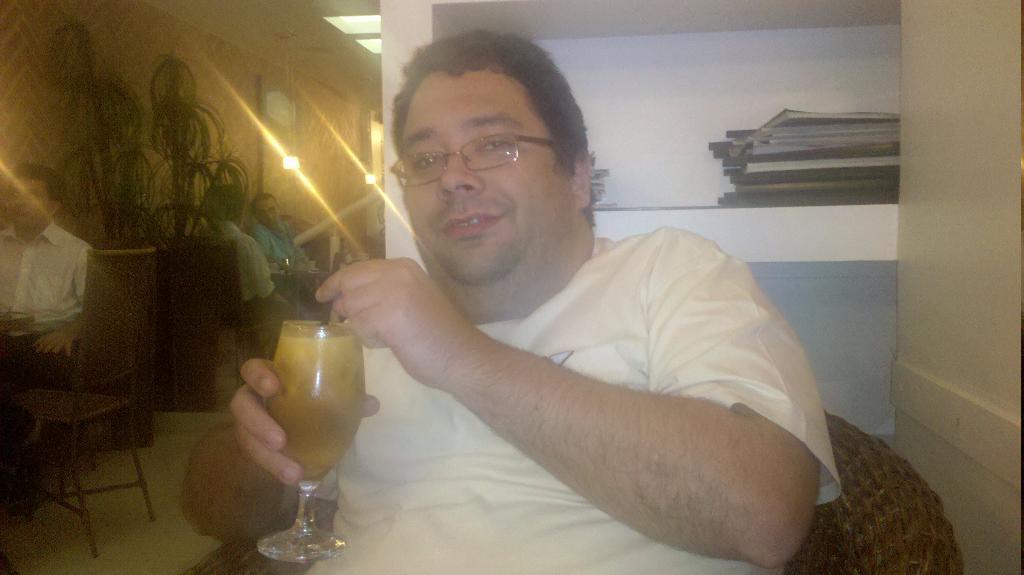In one or two sentences, can you explain what this image depicts? In the middle of the image a person is sitting and holding a glass. Behind him there is a wall, on the wall there are some books. On the left side of the image few people are sitting and there are some plants and tables. Behind them there is wall, on the wall there are some frames and lights. 